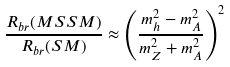<formula> <loc_0><loc_0><loc_500><loc_500>\frac { R _ { b r } ( M S S M ) } { R _ { b r } ( S M ) } \approx \left ( \frac { m _ { h } ^ { 2 } - m _ { A } ^ { 2 } } { m _ { Z } ^ { 2 } + m _ { A } ^ { 2 } } \right ) ^ { 2 }</formula> 